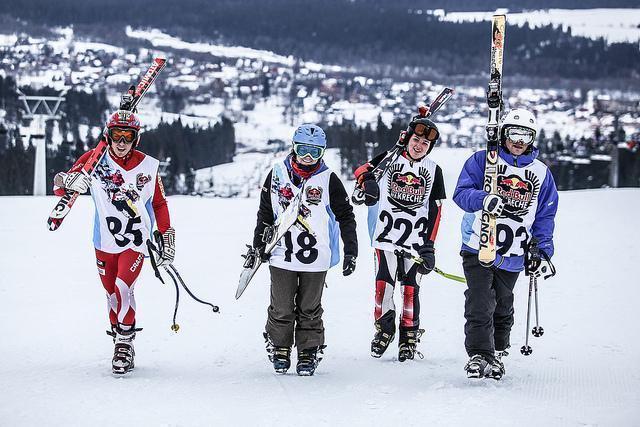How many of the 4 kids are holding skies?
From the following four choices, select the correct answer to address the question.
Options: 1/4, 4/4, 2/4, 3/4. 3/4. 